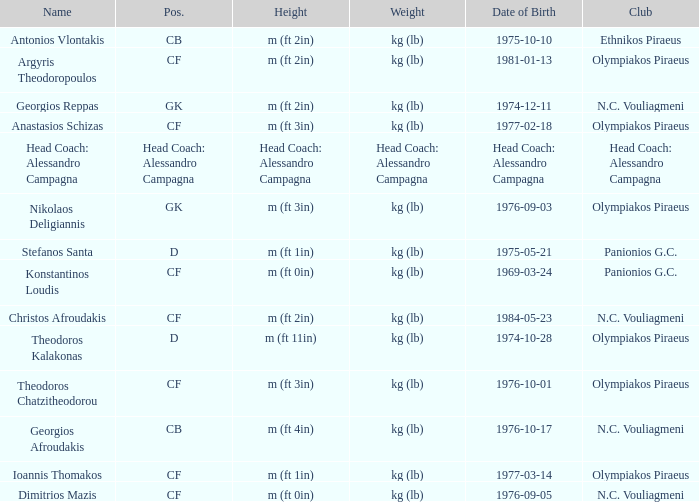What is the weight of the player from club panionios g.c. and was born on 1975-05-21? Kg (lb). 